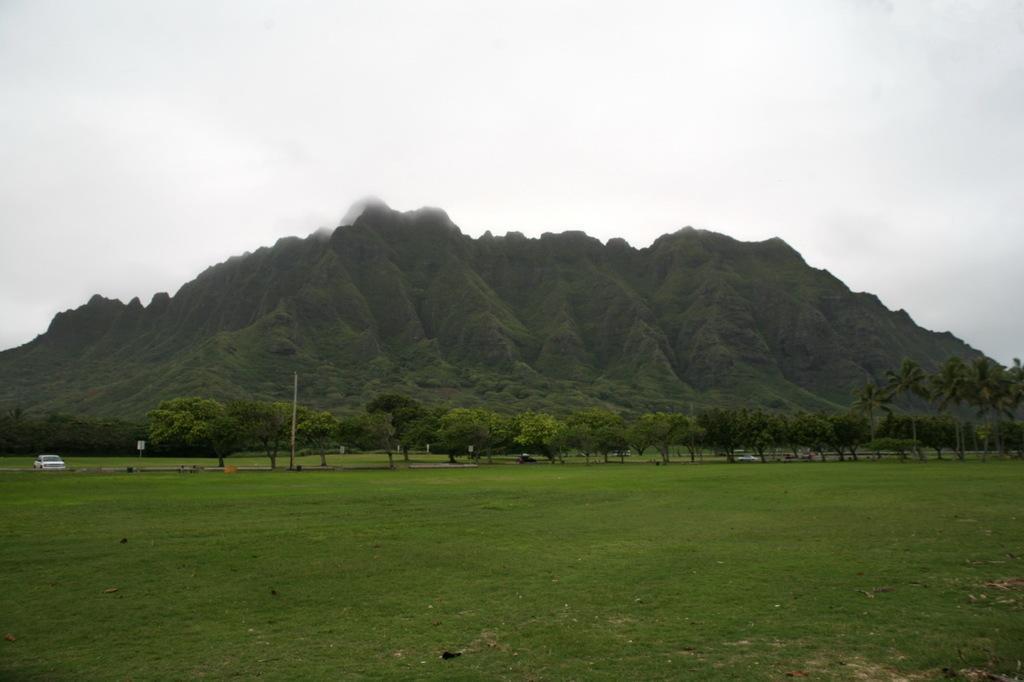Can you describe this image briefly? In this image we can see grassland, trees, vehicles moving on the road, palos, hills and the sky in the background. 